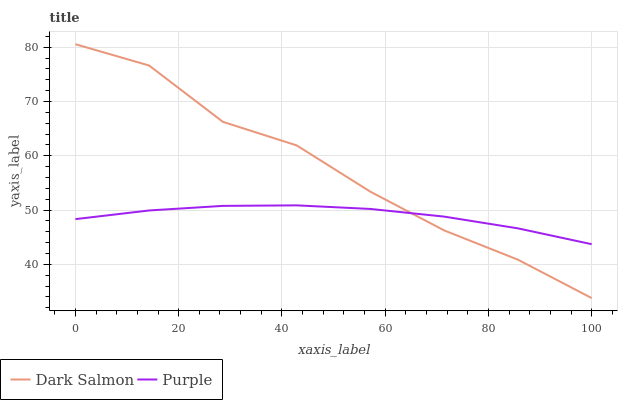Does Dark Salmon have the minimum area under the curve?
Answer yes or no. No. Is Dark Salmon the smoothest?
Answer yes or no. No. 